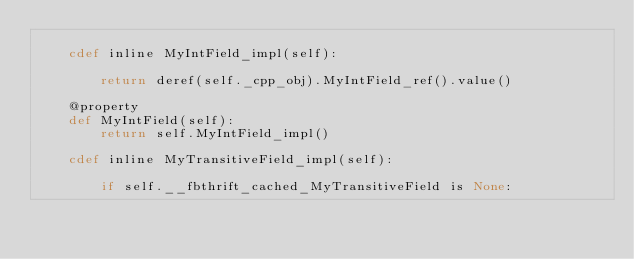<code> <loc_0><loc_0><loc_500><loc_500><_Cython_>
    cdef inline MyIntField_impl(self):

        return deref(self._cpp_obj).MyIntField_ref().value()

    @property
    def MyIntField(self):
        return self.MyIntField_impl()

    cdef inline MyTransitiveField_impl(self):

        if self.__fbthrift_cached_MyTransitiveField is None:</code> 